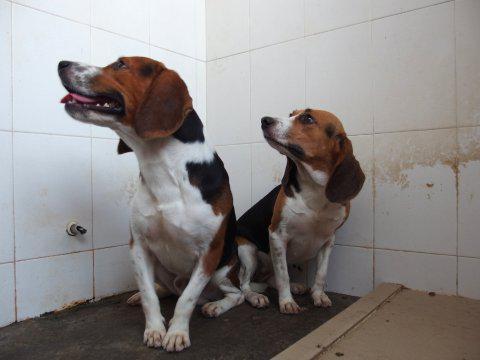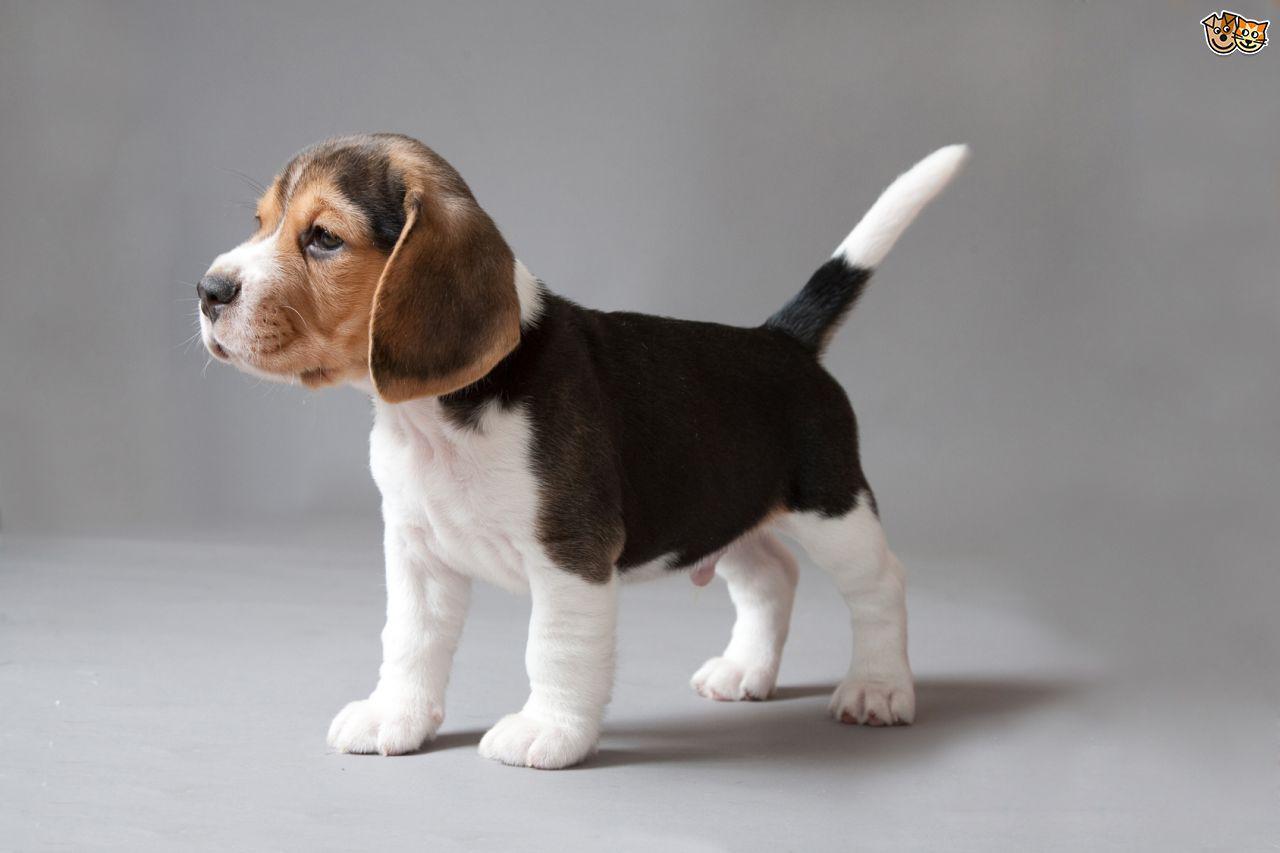The first image is the image on the left, the second image is the image on the right. Analyze the images presented: Is the assertion "In one of the images there is a real dog whose tail is standing up straight." valid? Answer yes or no. Yes. 